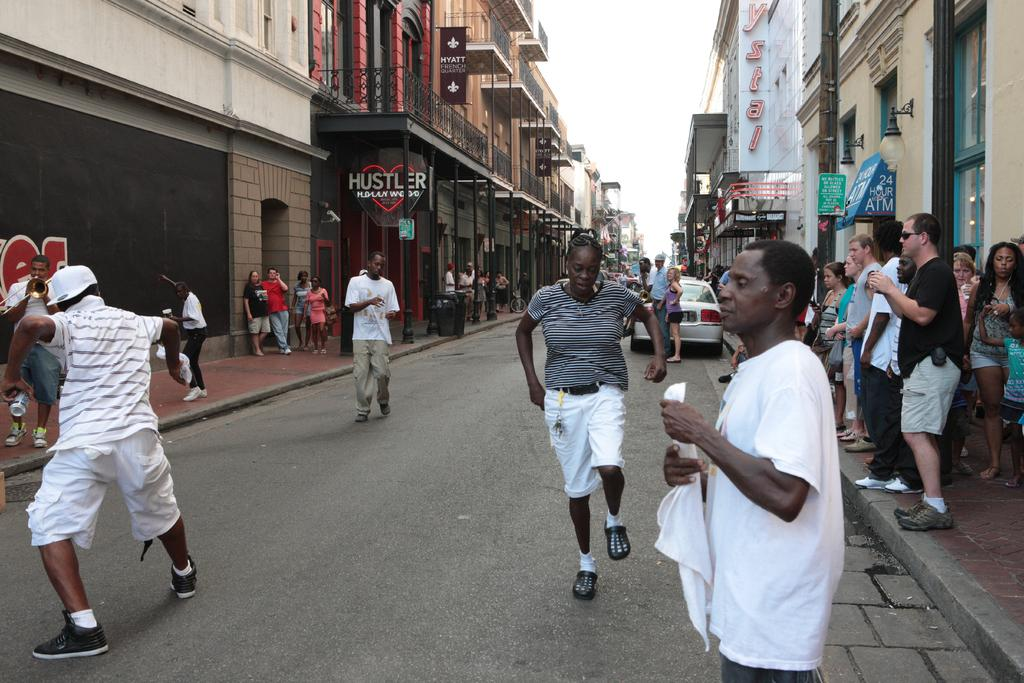What is the main feature in the center of the image? There is a road in the center of the image. What are the people on the road doing? People are present on the road, but their specific actions are not mentioned in the facts. Where are some people located in relation to the road? Some people are standing on the sidewalk. What can be seen in the background of the image? There are buildings, a car, and the sky visible in the background of the image. What color is the reaction of the people on the road? There is no mention of a reaction by the people on the road in the facts, and therefore no color can be assigned to it. 